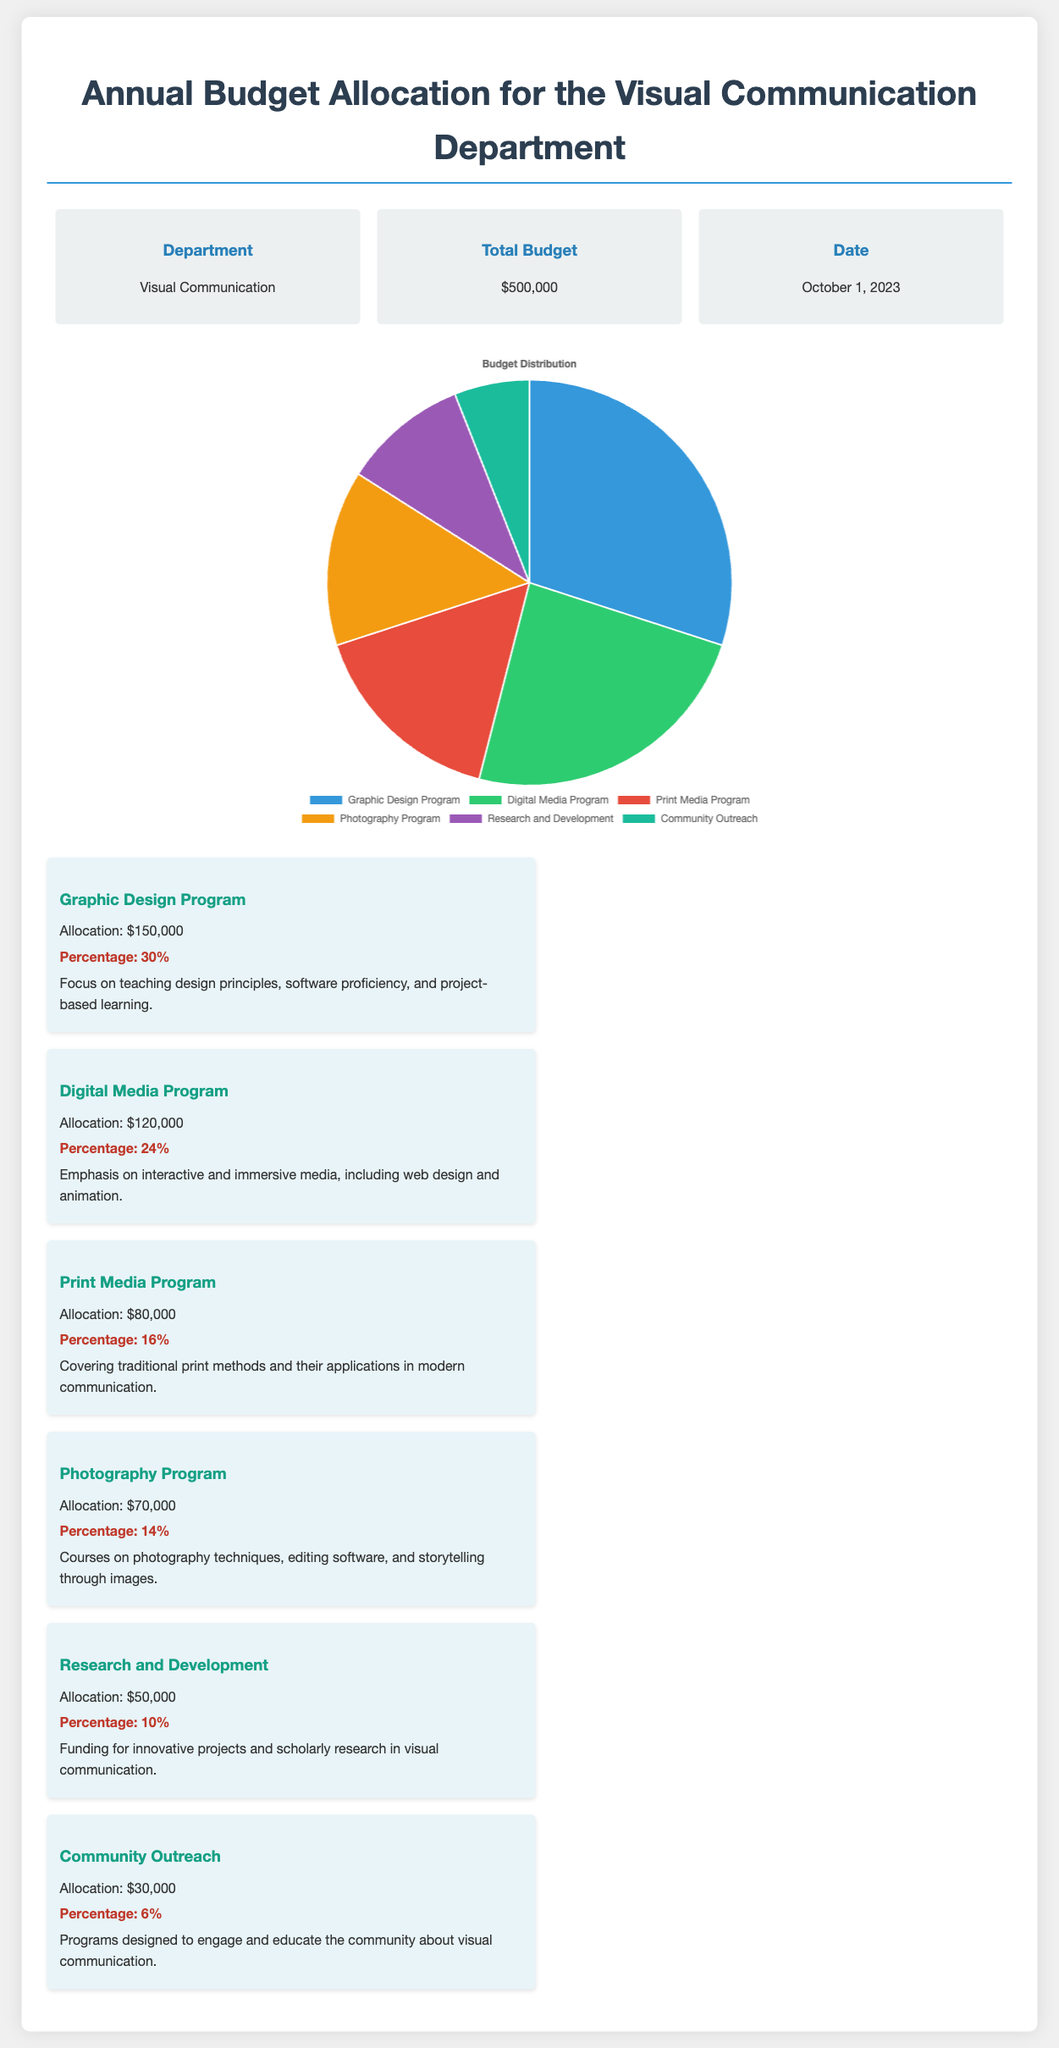What is the total budget for the Visual Communication Department? The total budget is explicitly stated in the document.
Answer: $500,000 What program receives the highest allocation? This is determined by comparing the allocation amounts across all programs listed.
Answer: Graphic Design Program What is the percentage allocation for the Digital Media Program? The document provides the specific percentage allocation for this program.
Answer: 24% What amount is allocated to the Community Outreach program? The allocation is specifically mentioned in the details for this program.
Answer: $30,000 How much of the budget is focused on Research and Development? This can be found directly in the allocation details provided for this category.
Answer: $50,000 Which program has the least budget allocation? By comparing all the allocation amounts, we can identify the program with the smallest budget.
Answer: Community Outreach What is the percentage of the Print Media Program budget? The document includes a specific percentage for this program that can be easily referenced.
Answer: 16% How many programs are listed in the budget allocation? This can be calculated by counting the distinct programs mentioned in the allocation details.
Answer: 6 What is the budget allocation for the Photography Program? The amount is directly referred to in the section describing the Photography Program.
Answer: $70,000 